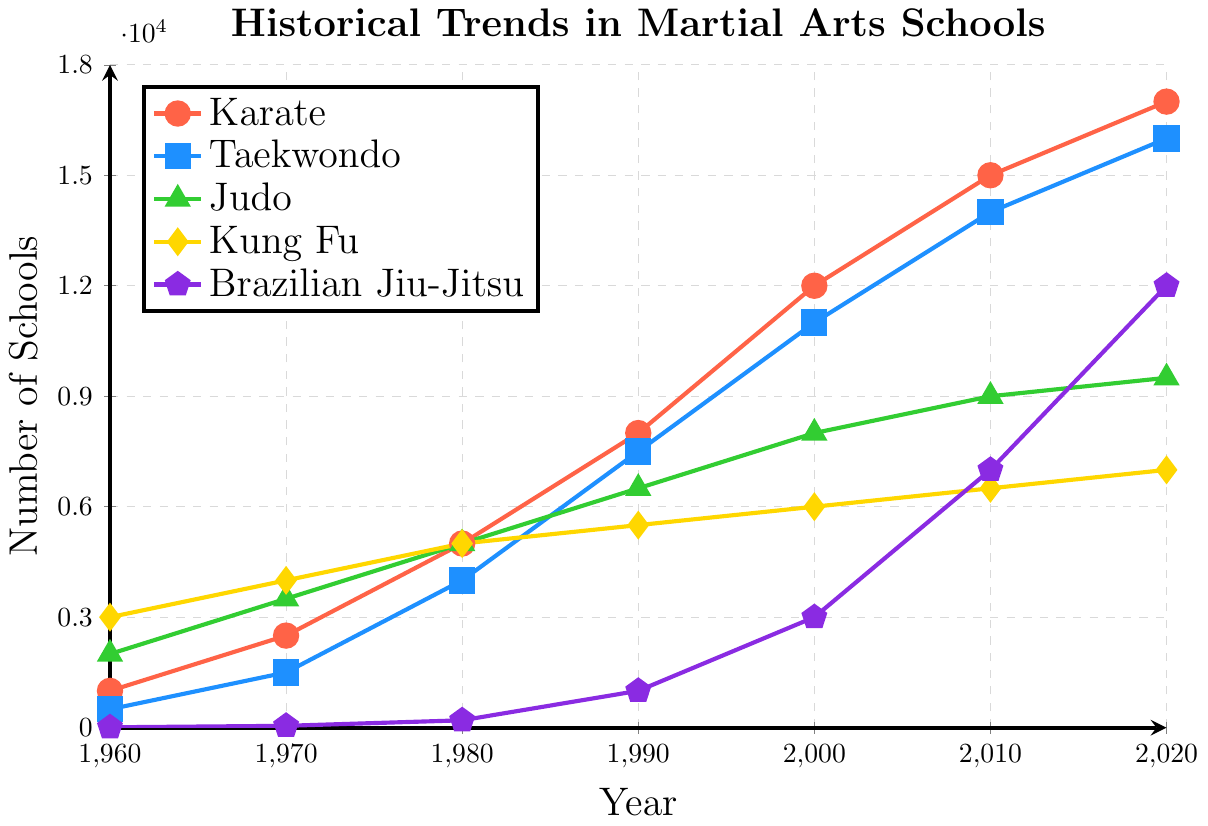Which martial art had the highest number of schools in 2020? By looking at the plot, observe the data points for the year 2020 and compare the values for each martial art. Brazilian Jiu-Jitsu has the highest number of schools at 12,000.
Answer: Brazilian Jiu-Jitsu What was the number of Taekwondo schools in 1980 compared to Judo schools in the same year? From the figure, find the data points for Taekwondo and Judo in 1980. Taekwondo had 4,000 schools, and Judo had 5,000 schools. Hence, Judo had more schools than Taekwondo in 1980.
Answer: Judo had more How did the number of Brazilian Jiu-Jitsu schools change between 2000 and 2010? Find the data points for Brazilian Jiu-Jitsu in 2000 and 2010 and compare them. In 2000, there were 3,000 schools, and in 2010, there were 7,000 schools. The number of schools increased by 4,000.
Answer: Increased by 4,000 Which martial art experienced the most significant growth in the number of schools from 1960 to 2020? Calculate the growth for each martial art by subtracting the value in 1960 from the value in 2020. Brazilian Jiu-Jitsu grew from 10 to 12,000, a growth of 11,990, which is the highest.
Answer: Brazilian Jiu-Jitsu On average, how many new Karate schools were added each decade from 1960 to 2020? Sum the number of Karate schools at each decade (2500-1000, 5000-2500, ...) divided by the number of decades (6). Total growth is (2500 + 2500 + 3000 + 4000 + 3000 + 2000 = 17000 - 1000 = 16000) over 6 decades. 16000/6 ~ 2667.
Answer: ~2667 In which year did Taekwondo schools surpass 10,000 in number? Locate the data points for Taekwondo and find where it first reaches above 10,000. In 2000, Taekwondo schools number 11,000, which is the first instance above 10,000.
Answer: 2000 Compare the trend of Kung Fu and Judo schools between 1970 and 2000. Identify the data points for both martial arts from 1970 to 2000 and analyze the trend. Judo increased from 3500 to 8000; Kung Fu increased from 4000 to 6000. Both increased, but Judo had a higher increase.
Answer: Judo increased more What is the average number of Judo schools across all the years listed? Sum the number of Judo schools for each year (2000 + 3500 + 5000 + 6500 + 8000 + 9000 + 9500 = 43500) and divide by the number of years (7). 43500/7 = 6214.3.
Answer: 6214.3 Which martial art showed the most stability in growth from 1960 to 2020? Examine the trend lines for each martial art and identify which one shows the least variation and most consistent growth. Kung Fu shows a steady increase every decade.
Answer: Kung Fu 